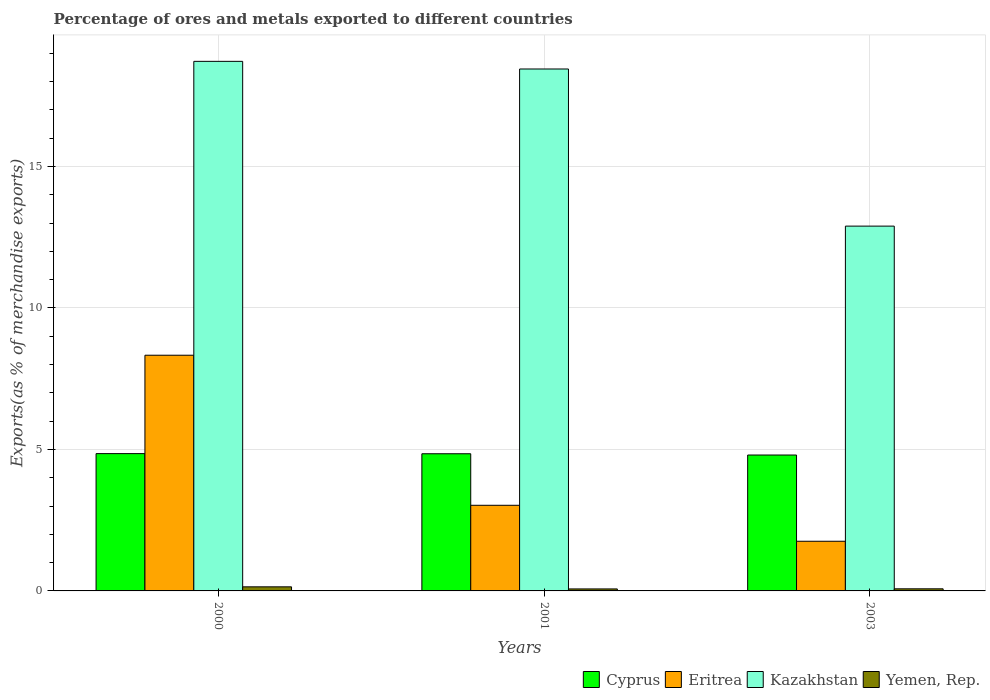How many groups of bars are there?
Your answer should be very brief. 3. Are the number of bars per tick equal to the number of legend labels?
Keep it short and to the point. Yes. How many bars are there on the 3rd tick from the left?
Make the answer very short. 4. In how many cases, is the number of bars for a given year not equal to the number of legend labels?
Your answer should be compact. 0. What is the percentage of exports to different countries in Cyprus in 2003?
Your answer should be very brief. 4.8. Across all years, what is the maximum percentage of exports to different countries in Cyprus?
Make the answer very short. 4.85. Across all years, what is the minimum percentage of exports to different countries in Yemen, Rep.?
Make the answer very short. 0.07. What is the total percentage of exports to different countries in Yemen, Rep. in the graph?
Keep it short and to the point. 0.29. What is the difference between the percentage of exports to different countries in Kazakhstan in 2000 and that in 2003?
Provide a short and direct response. 5.82. What is the difference between the percentage of exports to different countries in Eritrea in 2000 and the percentage of exports to different countries in Kazakhstan in 2001?
Provide a succinct answer. -10.11. What is the average percentage of exports to different countries in Kazakhstan per year?
Your answer should be very brief. 16.68. In the year 2003, what is the difference between the percentage of exports to different countries in Cyprus and percentage of exports to different countries in Eritrea?
Make the answer very short. 3.05. In how many years, is the percentage of exports to different countries in Kazakhstan greater than 4 %?
Your response must be concise. 3. What is the ratio of the percentage of exports to different countries in Cyprus in 2001 to that in 2003?
Your answer should be very brief. 1.01. Is the difference between the percentage of exports to different countries in Cyprus in 2000 and 2003 greater than the difference between the percentage of exports to different countries in Eritrea in 2000 and 2003?
Your response must be concise. No. What is the difference between the highest and the second highest percentage of exports to different countries in Kazakhstan?
Give a very brief answer. 0.27. What is the difference between the highest and the lowest percentage of exports to different countries in Kazakhstan?
Your answer should be compact. 5.82. Is the sum of the percentage of exports to different countries in Kazakhstan in 2001 and 2003 greater than the maximum percentage of exports to different countries in Yemen, Rep. across all years?
Provide a short and direct response. Yes. What does the 3rd bar from the left in 2000 represents?
Give a very brief answer. Kazakhstan. What does the 1st bar from the right in 2003 represents?
Keep it short and to the point. Yemen, Rep. What is the difference between two consecutive major ticks on the Y-axis?
Your answer should be compact. 5. Does the graph contain any zero values?
Make the answer very short. No. How many legend labels are there?
Offer a terse response. 4. What is the title of the graph?
Your response must be concise. Percentage of ores and metals exported to different countries. What is the label or title of the Y-axis?
Keep it short and to the point. Exports(as % of merchandise exports). What is the Exports(as % of merchandise exports) in Cyprus in 2000?
Give a very brief answer. 4.85. What is the Exports(as % of merchandise exports) in Eritrea in 2000?
Make the answer very short. 8.33. What is the Exports(as % of merchandise exports) of Kazakhstan in 2000?
Provide a succinct answer. 18.71. What is the Exports(as % of merchandise exports) in Yemen, Rep. in 2000?
Your answer should be compact. 0.14. What is the Exports(as % of merchandise exports) in Cyprus in 2001?
Your answer should be compact. 4.85. What is the Exports(as % of merchandise exports) in Eritrea in 2001?
Offer a very short reply. 3.03. What is the Exports(as % of merchandise exports) in Kazakhstan in 2001?
Provide a short and direct response. 18.44. What is the Exports(as % of merchandise exports) of Yemen, Rep. in 2001?
Give a very brief answer. 0.07. What is the Exports(as % of merchandise exports) in Cyprus in 2003?
Make the answer very short. 4.8. What is the Exports(as % of merchandise exports) in Eritrea in 2003?
Your answer should be very brief. 1.75. What is the Exports(as % of merchandise exports) of Kazakhstan in 2003?
Offer a very short reply. 12.89. What is the Exports(as % of merchandise exports) of Yemen, Rep. in 2003?
Your response must be concise. 0.07. Across all years, what is the maximum Exports(as % of merchandise exports) in Cyprus?
Your answer should be compact. 4.85. Across all years, what is the maximum Exports(as % of merchandise exports) in Eritrea?
Provide a succinct answer. 8.33. Across all years, what is the maximum Exports(as % of merchandise exports) in Kazakhstan?
Provide a succinct answer. 18.71. Across all years, what is the maximum Exports(as % of merchandise exports) in Yemen, Rep.?
Your answer should be compact. 0.14. Across all years, what is the minimum Exports(as % of merchandise exports) of Cyprus?
Your response must be concise. 4.8. Across all years, what is the minimum Exports(as % of merchandise exports) of Eritrea?
Offer a very short reply. 1.75. Across all years, what is the minimum Exports(as % of merchandise exports) of Kazakhstan?
Ensure brevity in your answer.  12.89. Across all years, what is the minimum Exports(as % of merchandise exports) in Yemen, Rep.?
Offer a very short reply. 0.07. What is the total Exports(as % of merchandise exports) of Cyprus in the graph?
Provide a short and direct response. 14.5. What is the total Exports(as % of merchandise exports) in Eritrea in the graph?
Offer a very short reply. 13.11. What is the total Exports(as % of merchandise exports) in Kazakhstan in the graph?
Your answer should be compact. 50.05. What is the total Exports(as % of merchandise exports) of Yemen, Rep. in the graph?
Your response must be concise. 0.29. What is the difference between the Exports(as % of merchandise exports) of Cyprus in 2000 and that in 2001?
Give a very brief answer. 0. What is the difference between the Exports(as % of merchandise exports) in Eritrea in 2000 and that in 2001?
Your answer should be compact. 5.3. What is the difference between the Exports(as % of merchandise exports) of Kazakhstan in 2000 and that in 2001?
Offer a very short reply. 0.27. What is the difference between the Exports(as % of merchandise exports) of Yemen, Rep. in 2000 and that in 2001?
Provide a short and direct response. 0.07. What is the difference between the Exports(as % of merchandise exports) of Cyprus in 2000 and that in 2003?
Your answer should be very brief. 0.05. What is the difference between the Exports(as % of merchandise exports) in Eritrea in 2000 and that in 2003?
Your answer should be very brief. 6.57. What is the difference between the Exports(as % of merchandise exports) of Kazakhstan in 2000 and that in 2003?
Your answer should be very brief. 5.82. What is the difference between the Exports(as % of merchandise exports) of Yemen, Rep. in 2000 and that in 2003?
Ensure brevity in your answer.  0.07. What is the difference between the Exports(as % of merchandise exports) of Cyprus in 2001 and that in 2003?
Provide a short and direct response. 0.04. What is the difference between the Exports(as % of merchandise exports) of Eritrea in 2001 and that in 2003?
Your answer should be very brief. 1.27. What is the difference between the Exports(as % of merchandise exports) of Kazakhstan in 2001 and that in 2003?
Your response must be concise. 5.55. What is the difference between the Exports(as % of merchandise exports) in Yemen, Rep. in 2001 and that in 2003?
Offer a terse response. -0. What is the difference between the Exports(as % of merchandise exports) in Cyprus in 2000 and the Exports(as % of merchandise exports) in Eritrea in 2001?
Offer a terse response. 1.83. What is the difference between the Exports(as % of merchandise exports) in Cyprus in 2000 and the Exports(as % of merchandise exports) in Kazakhstan in 2001?
Provide a succinct answer. -13.59. What is the difference between the Exports(as % of merchandise exports) of Cyprus in 2000 and the Exports(as % of merchandise exports) of Yemen, Rep. in 2001?
Offer a terse response. 4.78. What is the difference between the Exports(as % of merchandise exports) of Eritrea in 2000 and the Exports(as % of merchandise exports) of Kazakhstan in 2001?
Provide a short and direct response. -10.11. What is the difference between the Exports(as % of merchandise exports) of Eritrea in 2000 and the Exports(as % of merchandise exports) of Yemen, Rep. in 2001?
Offer a terse response. 8.26. What is the difference between the Exports(as % of merchandise exports) in Kazakhstan in 2000 and the Exports(as % of merchandise exports) in Yemen, Rep. in 2001?
Give a very brief answer. 18.64. What is the difference between the Exports(as % of merchandise exports) in Cyprus in 2000 and the Exports(as % of merchandise exports) in Eritrea in 2003?
Provide a short and direct response. 3.1. What is the difference between the Exports(as % of merchandise exports) in Cyprus in 2000 and the Exports(as % of merchandise exports) in Kazakhstan in 2003?
Ensure brevity in your answer.  -8.04. What is the difference between the Exports(as % of merchandise exports) of Cyprus in 2000 and the Exports(as % of merchandise exports) of Yemen, Rep. in 2003?
Ensure brevity in your answer.  4.78. What is the difference between the Exports(as % of merchandise exports) in Eritrea in 2000 and the Exports(as % of merchandise exports) in Kazakhstan in 2003?
Your answer should be compact. -4.56. What is the difference between the Exports(as % of merchandise exports) in Eritrea in 2000 and the Exports(as % of merchandise exports) in Yemen, Rep. in 2003?
Your answer should be compact. 8.25. What is the difference between the Exports(as % of merchandise exports) of Kazakhstan in 2000 and the Exports(as % of merchandise exports) of Yemen, Rep. in 2003?
Your answer should be very brief. 18.64. What is the difference between the Exports(as % of merchandise exports) of Cyprus in 2001 and the Exports(as % of merchandise exports) of Eritrea in 2003?
Your response must be concise. 3.09. What is the difference between the Exports(as % of merchandise exports) of Cyprus in 2001 and the Exports(as % of merchandise exports) of Kazakhstan in 2003?
Offer a very short reply. -8.04. What is the difference between the Exports(as % of merchandise exports) of Cyprus in 2001 and the Exports(as % of merchandise exports) of Yemen, Rep. in 2003?
Your answer should be compact. 4.77. What is the difference between the Exports(as % of merchandise exports) in Eritrea in 2001 and the Exports(as % of merchandise exports) in Kazakhstan in 2003?
Give a very brief answer. -9.86. What is the difference between the Exports(as % of merchandise exports) of Eritrea in 2001 and the Exports(as % of merchandise exports) of Yemen, Rep. in 2003?
Give a very brief answer. 2.95. What is the difference between the Exports(as % of merchandise exports) of Kazakhstan in 2001 and the Exports(as % of merchandise exports) of Yemen, Rep. in 2003?
Offer a very short reply. 18.37. What is the average Exports(as % of merchandise exports) in Cyprus per year?
Give a very brief answer. 4.83. What is the average Exports(as % of merchandise exports) of Eritrea per year?
Make the answer very short. 4.37. What is the average Exports(as % of merchandise exports) of Kazakhstan per year?
Offer a terse response. 16.68. What is the average Exports(as % of merchandise exports) in Yemen, Rep. per year?
Your response must be concise. 0.1. In the year 2000, what is the difference between the Exports(as % of merchandise exports) of Cyprus and Exports(as % of merchandise exports) of Eritrea?
Ensure brevity in your answer.  -3.48. In the year 2000, what is the difference between the Exports(as % of merchandise exports) of Cyprus and Exports(as % of merchandise exports) of Kazakhstan?
Keep it short and to the point. -13.86. In the year 2000, what is the difference between the Exports(as % of merchandise exports) of Cyprus and Exports(as % of merchandise exports) of Yemen, Rep.?
Offer a terse response. 4.71. In the year 2000, what is the difference between the Exports(as % of merchandise exports) in Eritrea and Exports(as % of merchandise exports) in Kazakhstan?
Provide a succinct answer. -10.38. In the year 2000, what is the difference between the Exports(as % of merchandise exports) of Eritrea and Exports(as % of merchandise exports) of Yemen, Rep.?
Provide a short and direct response. 8.18. In the year 2000, what is the difference between the Exports(as % of merchandise exports) of Kazakhstan and Exports(as % of merchandise exports) of Yemen, Rep.?
Provide a succinct answer. 18.57. In the year 2001, what is the difference between the Exports(as % of merchandise exports) of Cyprus and Exports(as % of merchandise exports) of Eritrea?
Your answer should be very brief. 1.82. In the year 2001, what is the difference between the Exports(as % of merchandise exports) in Cyprus and Exports(as % of merchandise exports) in Kazakhstan?
Give a very brief answer. -13.6. In the year 2001, what is the difference between the Exports(as % of merchandise exports) in Cyprus and Exports(as % of merchandise exports) in Yemen, Rep.?
Your answer should be very brief. 4.78. In the year 2001, what is the difference between the Exports(as % of merchandise exports) of Eritrea and Exports(as % of merchandise exports) of Kazakhstan?
Provide a succinct answer. -15.42. In the year 2001, what is the difference between the Exports(as % of merchandise exports) of Eritrea and Exports(as % of merchandise exports) of Yemen, Rep.?
Provide a succinct answer. 2.96. In the year 2001, what is the difference between the Exports(as % of merchandise exports) of Kazakhstan and Exports(as % of merchandise exports) of Yemen, Rep.?
Offer a terse response. 18.37. In the year 2003, what is the difference between the Exports(as % of merchandise exports) of Cyprus and Exports(as % of merchandise exports) of Eritrea?
Your answer should be very brief. 3.05. In the year 2003, what is the difference between the Exports(as % of merchandise exports) of Cyprus and Exports(as % of merchandise exports) of Kazakhstan?
Offer a very short reply. -8.09. In the year 2003, what is the difference between the Exports(as % of merchandise exports) of Cyprus and Exports(as % of merchandise exports) of Yemen, Rep.?
Provide a succinct answer. 4.73. In the year 2003, what is the difference between the Exports(as % of merchandise exports) of Eritrea and Exports(as % of merchandise exports) of Kazakhstan?
Ensure brevity in your answer.  -11.14. In the year 2003, what is the difference between the Exports(as % of merchandise exports) of Eritrea and Exports(as % of merchandise exports) of Yemen, Rep.?
Your answer should be very brief. 1.68. In the year 2003, what is the difference between the Exports(as % of merchandise exports) of Kazakhstan and Exports(as % of merchandise exports) of Yemen, Rep.?
Make the answer very short. 12.82. What is the ratio of the Exports(as % of merchandise exports) of Cyprus in 2000 to that in 2001?
Your response must be concise. 1. What is the ratio of the Exports(as % of merchandise exports) in Eritrea in 2000 to that in 2001?
Keep it short and to the point. 2.75. What is the ratio of the Exports(as % of merchandise exports) in Kazakhstan in 2000 to that in 2001?
Make the answer very short. 1.01. What is the ratio of the Exports(as % of merchandise exports) in Yemen, Rep. in 2000 to that in 2001?
Make the answer very short. 2.05. What is the ratio of the Exports(as % of merchandise exports) in Cyprus in 2000 to that in 2003?
Your answer should be very brief. 1.01. What is the ratio of the Exports(as % of merchandise exports) in Eritrea in 2000 to that in 2003?
Give a very brief answer. 4.75. What is the ratio of the Exports(as % of merchandise exports) of Kazakhstan in 2000 to that in 2003?
Provide a succinct answer. 1.45. What is the ratio of the Exports(as % of merchandise exports) in Yemen, Rep. in 2000 to that in 2003?
Your answer should be very brief. 1.94. What is the ratio of the Exports(as % of merchandise exports) of Cyprus in 2001 to that in 2003?
Keep it short and to the point. 1.01. What is the ratio of the Exports(as % of merchandise exports) in Eritrea in 2001 to that in 2003?
Provide a short and direct response. 1.72. What is the ratio of the Exports(as % of merchandise exports) in Kazakhstan in 2001 to that in 2003?
Your response must be concise. 1.43. What is the ratio of the Exports(as % of merchandise exports) in Yemen, Rep. in 2001 to that in 2003?
Your answer should be compact. 0.95. What is the difference between the highest and the second highest Exports(as % of merchandise exports) of Cyprus?
Keep it short and to the point. 0. What is the difference between the highest and the second highest Exports(as % of merchandise exports) of Eritrea?
Your answer should be compact. 5.3. What is the difference between the highest and the second highest Exports(as % of merchandise exports) of Kazakhstan?
Make the answer very short. 0.27. What is the difference between the highest and the second highest Exports(as % of merchandise exports) in Yemen, Rep.?
Make the answer very short. 0.07. What is the difference between the highest and the lowest Exports(as % of merchandise exports) in Cyprus?
Give a very brief answer. 0.05. What is the difference between the highest and the lowest Exports(as % of merchandise exports) of Eritrea?
Provide a short and direct response. 6.57. What is the difference between the highest and the lowest Exports(as % of merchandise exports) of Kazakhstan?
Your response must be concise. 5.82. What is the difference between the highest and the lowest Exports(as % of merchandise exports) of Yemen, Rep.?
Make the answer very short. 0.07. 